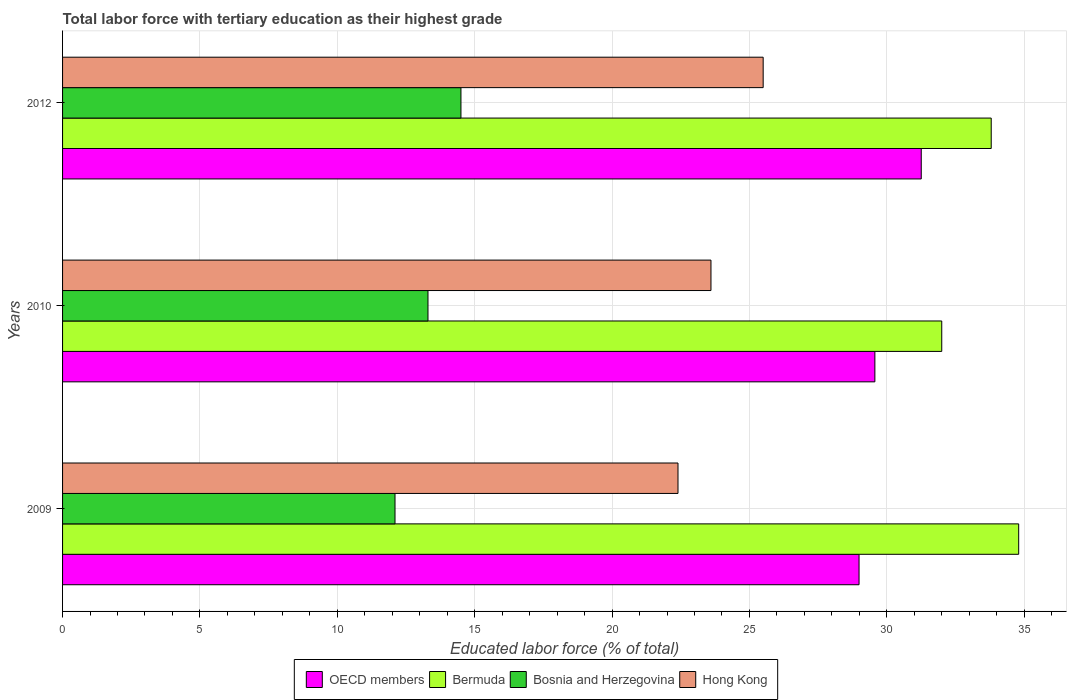How many different coloured bars are there?
Offer a very short reply. 4. Are the number of bars on each tick of the Y-axis equal?
Keep it short and to the point. Yes. How many bars are there on the 1st tick from the top?
Offer a terse response. 4. How many bars are there on the 1st tick from the bottom?
Offer a terse response. 4. What is the percentage of male labor force with tertiary education in Bermuda in 2012?
Give a very brief answer. 33.8. Across all years, what is the maximum percentage of male labor force with tertiary education in OECD members?
Provide a short and direct response. 31.25. Across all years, what is the minimum percentage of male labor force with tertiary education in Bosnia and Herzegovina?
Give a very brief answer. 12.1. In which year was the percentage of male labor force with tertiary education in Bosnia and Herzegovina minimum?
Keep it short and to the point. 2009. What is the total percentage of male labor force with tertiary education in Bermuda in the graph?
Provide a succinct answer. 100.6. What is the difference between the percentage of male labor force with tertiary education in Bosnia and Herzegovina in 2010 and that in 2012?
Provide a short and direct response. -1.2. What is the difference between the percentage of male labor force with tertiary education in Hong Kong in 2009 and the percentage of male labor force with tertiary education in Bermuda in 2012?
Your answer should be compact. -11.4. What is the average percentage of male labor force with tertiary education in Hong Kong per year?
Offer a terse response. 23.83. In the year 2010, what is the difference between the percentage of male labor force with tertiary education in OECD members and percentage of male labor force with tertiary education in Bosnia and Herzegovina?
Provide a succinct answer. 16.27. In how many years, is the percentage of male labor force with tertiary education in Bermuda greater than 30 %?
Ensure brevity in your answer.  3. What is the ratio of the percentage of male labor force with tertiary education in Hong Kong in 2009 to that in 2010?
Give a very brief answer. 0.95. What is the difference between the highest and the second highest percentage of male labor force with tertiary education in Bosnia and Herzegovina?
Ensure brevity in your answer.  1.2. What is the difference between the highest and the lowest percentage of male labor force with tertiary education in OECD members?
Your answer should be compact. 2.26. In how many years, is the percentage of male labor force with tertiary education in OECD members greater than the average percentage of male labor force with tertiary education in OECD members taken over all years?
Your answer should be very brief. 1. Is the sum of the percentage of male labor force with tertiary education in Bermuda in 2010 and 2012 greater than the maximum percentage of male labor force with tertiary education in Bosnia and Herzegovina across all years?
Keep it short and to the point. Yes. What does the 4th bar from the top in 2009 represents?
Ensure brevity in your answer.  OECD members. What does the 4th bar from the bottom in 2009 represents?
Your response must be concise. Hong Kong. Is it the case that in every year, the sum of the percentage of male labor force with tertiary education in OECD members and percentage of male labor force with tertiary education in Hong Kong is greater than the percentage of male labor force with tertiary education in Bermuda?
Give a very brief answer. Yes. How many bars are there?
Provide a short and direct response. 12. Are all the bars in the graph horizontal?
Keep it short and to the point. Yes. What is the difference between two consecutive major ticks on the X-axis?
Make the answer very short. 5. Does the graph contain any zero values?
Provide a short and direct response. No. Does the graph contain grids?
Keep it short and to the point. Yes. How many legend labels are there?
Provide a succinct answer. 4. How are the legend labels stacked?
Offer a very short reply. Horizontal. What is the title of the graph?
Provide a short and direct response. Total labor force with tertiary education as their highest grade. Does "North America" appear as one of the legend labels in the graph?
Offer a very short reply. No. What is the label or title of the X-axis?
Give a very brief answer. Educated labor force (% of total). What is the Educated labor force (% of total) of OECD members in 2009?
Offer a terse response. 28.99. What is the Educated labor force (% of total) of Bermuda in 2009?
Give a very brief answer. 34.8. What is the Educated labor force (% of total) of Bosnia and Herzegovina in 2009?
Your answer should be compact. 12.1. What is the Educated labor force (% of total) of Hong Kong in 2009?
Give a very brief answer. 22.4. What is the Educated labor force (% of total) in OECD members in 2010?
Make the answer very short. 29.57. What is the Educated labor force (% of total) in Bermuda in 2010?
Your answer should be very brief. 32. What is the Educated labor force (% of total) of Bosnia and Herzegovina in 2010?
Offer a very short reply. 13.3. What is the Educated labor force (% of total) in Hong Kong in 2010?
Ensure brevity in your answer.  23.6. What is the Educated labor force (% of total) of OECD members in 2012?
Provide a short and direct response. 31.25. What is the Educated labor force (% of total) of Bermuda in 2012?
Your answer should be very brief. 33.8. What is the Educated labor force (% of total) in Bosnia and Herzegovina in 2012?
Provide a short and direct response. 14.5. Across all years, what is the maximum Educated labor force (% of total) of OECD members?
Keep it short and to the point. 31.25. Across all years, what is the maximum Educated labor force (% of total) of Bermuda?
Give a very brief answer. 34.8. Across all years, what is the maximum Educated labor force (% of total) of Bosnia and Herzegovina?
Keep it short and to the point. 14.5. Across all years, what is the maximum Educated labor force (% of total) of Hong Kong?
Your answer should be very brief. 25.5. Across all years, what is the minimum Educated labor force (% of total) in OECD members?
Offer a very short reply. 28.99. Across all years, what is the minimum Educated labor force (% of total) in Bosnia and Herzegovina?
Keep it short and to the point. 12.1. Across all years, what is the minimum Educated labor force (% of total) in Hong Kong?
Your answer should be very brief. 22.4. What is the total Educated labor force (% of total) of OECD members in the graph?
Make the answer very short. 89.81. What is the total Educated labor force (% of total) in Bermuda in the graph?
Offer a very short reply. 100.6. What is the total Educated labor force (% of total) of Bosnia and Herzegovina in the graph?
Offer a very short reply. 39.9. What is the total Educated labor force (% of total) in Hong Kong in the graph?
Keep it short and to the point. 71.5. What is the difference between the Educated labor force (% of total) of OECD members in 2009 and that in 2010?
Your response must be concise. -0.58. What is the difference between the Educated labor force (% of total) of Bermuda in 2009 and that in 2010?
Keep it short and to the point. 2.8. What is the difference between the Educated labor force (% of total) of Hong Kong in 2009 and that in 2010?
Your response must be concise. -1.2. What is the difference between the Educated labor force (% of total) in OECD members in 2009 and that in 2012?
Offer a very short reply. -2.26. What is the difference between the Educated labor force (% of total) in Bermuda in 2009 and that in 2012?
Keep it short and to the point. 1. What is the difference between the Educated labor force (% of total) of Bosnia and Herzegovina in 2009 and that in 2012?
Your answer should be very brief. -2.4. What is the difference between the Educated labor force (% of total) in Hong Kong in 2009 and that in 2012?
Your answer should be very brief. -3.1. What is the difference between the Educated labor force (% of total) of OECD members in 2010 and that in 2012?
Offer a terse response. -1.69. What is the difference between the Educated labor force (% of total) of Bosnia and Herzegovina in 2010 and that in 2012?
Ensure brevity in your answer.  -1.2. What is the difference between the Educated labor force (% of total) of Hong Kong in 2010 and that in 2012?
Keep it short and to the point. -1.9. What is the difference between the Educated labor force (% of total) of OECD members in 2009 and the Educated labor force (% of total) of Bermuda in 2010?
Provide a succinct answer. -3.01. What is the difference between the Educated labor force (% of total) in OECD members in 2009 and the Educated labor force (% of total) in Bosnia and Herzegovina in 2010?
Provide a short and direct response. 15.69. What is the difference between the Educated labor force (% of total) of OECD members in 2009 and the Educated labor force (% of total) of Hong Kong in 2010?
Your answer should be very brief. 5.39. What is the difference between the Educated labor force (% of total) in Bosnia and Herzegovina in 2009 and the Educated labor force (% of total) in Hong Kong in 2010?
Your answer should be compact. -11.5. What is the difference between the Educated labor force (% of total) in OECD members in 2009 and the Educated labor force (% of total) in Bermuda in 2012?
Your answer should be compact. -4.81. What is the difference between the Educated labor force (% of total) in OECD members in 2009 and the Educated labor force (% of total) in Bosnia and Herzegovina in 2012?
Offer a terse response. 14.49. What is the difference between the Educated labor force (% of total) of OECD members in 2009 and the Educated labor force (% of total) of Hong Kong in 2012?
Your response must be concise. 3.49. What is the difference between the Educated labor force (% of total) of Bermuda in 2009 and the Educated labor force (% of total) of Bosnia and Herzegovina in 2012?
Your response must be concise. 20.3. What is the difference between the Educated labor force (% of total) of OECD members in 2010 and the Educated labor force (% of total) of Bermuda in 2012?
Offer a terse response. -4.23. What is the difference between the Educated labor force (% of total) of OECD members in 2010 and the Educated labor force (% of total) of Bosnia and Herzegovina in 2012?
Your answer should be very brief. 15.07. What is the difference between the Educated labor force (% of total) of OECD members in 2010 and the Educated labor force (% of total) of Hong Kong in 2012?
Ensure brevity in your answer.  4.07. What is the difference between the Educated labor force (% of total) in Bermuda in 2010 and the Educated labor force (% of total) in Hong Kong in 2012?
Make the answer very short. 6.5. What is the difference between the Educated labor force (% of total) in Bosnia and Herzegovina in 2010 and the Educated labor force (% of total) in Hong Kong in 2012?
Keep it short and to the point. -12.2. What is the average Educated labor force (% of total) of OECD members per year?
Give a very brief answer. 29.94. What is the average Educated labor force (% of total) of Bermuda per year?
Make the answer very short. 33.53. What is the average Educated labor force (% of total) of Bosnia and Herzegovina per year?
Provide a succinct answer. 13.3. What is the average Educated labor force (% of total) of Hong Kong per year?
Offer a very short reply. 23.83. In the year 2009, what is the difference between the Educated labor force (% of total) of OECD members and Educated labor force (% of total) of Bermuda?
Your answer should be compact. -5.81. In the year 2009, what is the difference between the Educated labor force (% of total) in OECD members and Educated labor force (% of total) in Bosnia and Herzegovina?
Offer a very short reply. 16.89. In the year 2009, what is the difference between the Educated labor force (% of total) of OECD members and Educated labor force (% of total) of Hong Kong?
Provide a short and direct response. 6.59. In the year 2009, what is the difference between the Educated labor force (% of total) in Bermuda and Educated labor force (% of total) in Bosnia and Herzegovina?
Your answer should be very brief. 22.7. In the year 2010, what is the difference between the Educated labor force (% of total) of OECD members and Educated labor force (% of total) of Bermuda?
Give a very brief answer. -2.43. In the year 2010, what is the difference between the Educated labor force (% of total) in OECD members and Educated labor force (% of total) in Bosnia and Herzegovina?
Provide a short and direct response. 16.27. In the year 2010, what is the difference between the Educated labor force (% of total) in OECD members and Educated labor force (% of total) in Hong Kong?
Your answer should be compact. 5.97. In the year 2010, what is the difference between the Educated labor force (% of total) of Bermuda and Educated labor force (% of total) of Bosnia and Herzegovina?
Your answer should be very brief. 18.7. In the year 2010, what is the difference between the Educated labor force (% of total) of Bermuda and Educated labor force (% of total) of Hong Kong?
Ensure brevity in your answer.  8.4. In the year 2010, what is the difference between the Educated labor force (% of total) in Bosnia and Herzegovina and Educated labor force (% of total) in Hong Kong?
Your response must be concise. -10.3. In the year 2012, what is the difference between the Educated labor force (% of total) in OECD members and Educated labor force (% of total) in Bermuda?
Make the answer very short. -2.55. In the year 2012, what is the difference between the Educated labor force (% of total) in OECD members and Educated labor force (% of total) in Bosnia and Herzegovina?
Provide a succinct answer. 16.75. In the year 2012, what is the difference between the Educated labor force (% of total) in OECD members and Educated labor force (% of total) in Hong Kong?
Your answer should be very brief. 5.75. In the year 2012, what is the difference between the Educated labor force (% of total) of Bermuda and Educated labor force (% of total) of Bosnia and Herzegovina?
Offer a very short reply. 19.3. What is the ratio of the Educated labor force (% of total) in OECD members in 2009 to that in 2010?
Give a very brief answer. 0.98. What is the ratio of the Educated labor force (% of total) of Bermuda in 2009 to that in 2010?
Your answer should be very brief. 1.09. What is the ratio of the Educated labor force (% of total) in Bosnia and Herzegovina in 2009 to that in 2010?
Offer a very short reply. 0.91. What is the ratio of the Educated labor force (% of total) in Hong Kong in 2009 to that in 2010?
Provide a succinct answer. 0.95. What is the ratio of the Educated labor force (% of total) of OECD members in 2009 to that in 2012?
Offer a terse response. 0.93. What is the ratio of the Educated labor force (% of total) of Bermuda in 2009 to that in 2012?
Give a very brief answer. 1.03. What is the ratio of the Educated labor force (% of total) of Bosnia and Herzegovina in 2009 to that in 2012?
Your answer should be very brief. 0.83. What is the ratio of the Educated labor force (% of total) of Hong Kong in 2009 to that in 2012?
Make the answer very short. 0.88. What is the ratio of the Educated labor force (% of total) of OECD members in 2010 to that in 2012?
Your answer should be very brief. 0.95. What is the ratio of the Educated labor force (% of total) in Bermuda in 2010 to that in 2012?
Your answer should be very brief. 0.95. What is the ratio of the Educated labor force (% of total) in Bosnia and Herzegovina in 2010 to that in 2012?
Your response must be concise. 0.92. What is the ratio of the Educated labor force (% of total) in Hong Kong in 2010 to that in 2012?
Provide a succinct answer. 0.93. What is the difference between the highest and the second highest Educated labor force (% of total) of OECD members?
Give a very brief answer. 1.69. What is the difference between the highest and the second highest Educated labor force (% of total) in Bermuda?
Provide a succinct answer. 1. What is the difference between the highest and the lowest Educated labor force (% of total) in OECD members?
Provide a succinct answer. 2.26. 